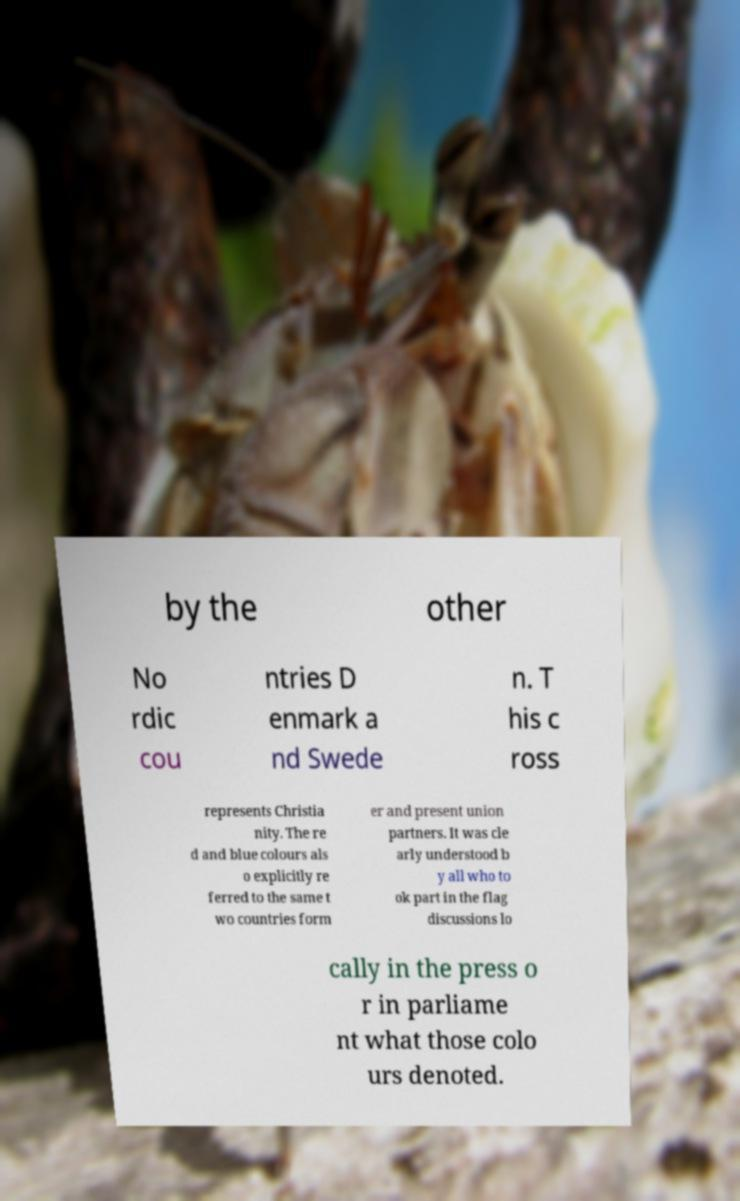There's text embedded in this image that I need extracted. Can you transcribe it verbatim? by the other No rdic cou ntries D enmark a nd Swede n. T his c ross represents Christia nity. The re d and blue colours als o explicitly re ferred to the same t wo countries form er and present union partners. It was cle arly understood b y all who to ok part in the flag discussions lo cally in the press o r in parliame nt what those colo urs denoted. 